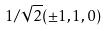<formula> <loc_0><loc_0><loc_500><loc_500>1 / \sqrt { 2 } ( \pm 1 , 1 , 0 )</formula> 